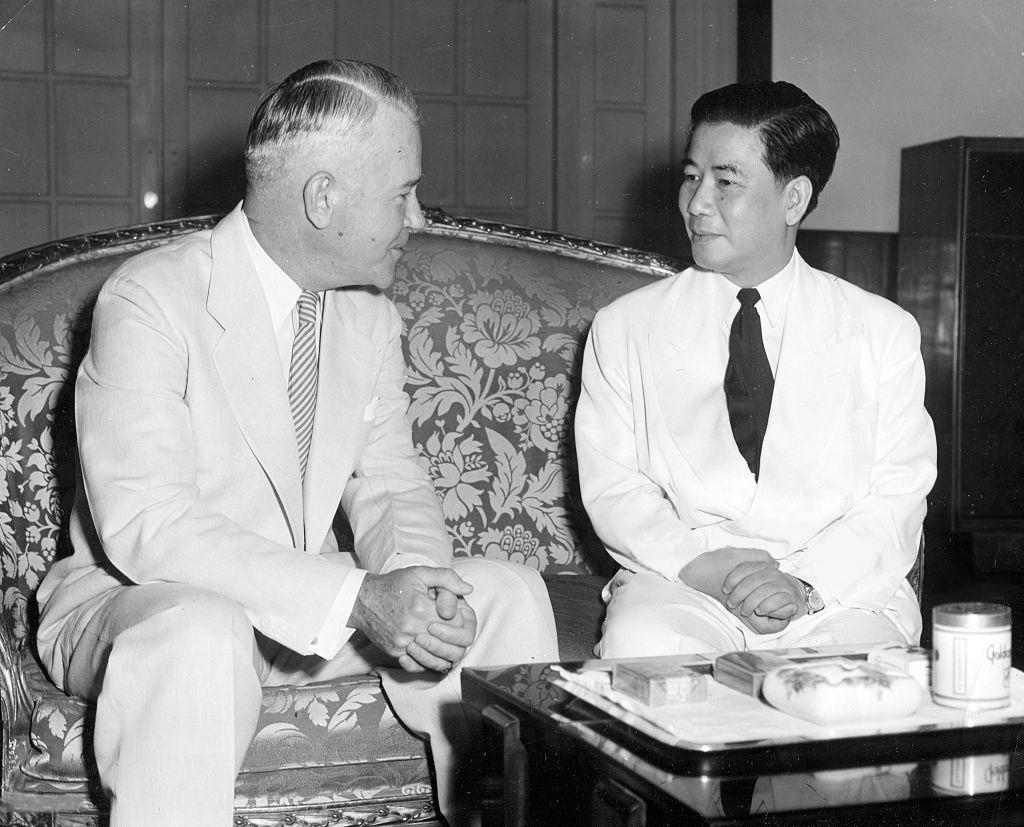In one or two sentences, can you explain what this image depicts? In this image There are two mans sitting on the couch. On the table there are some objects. 